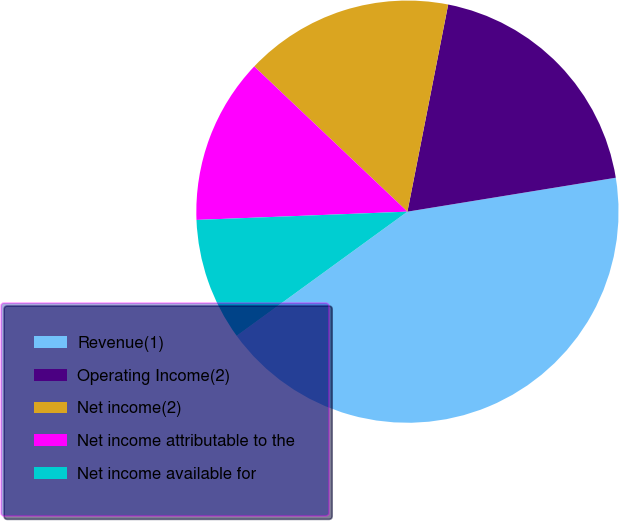Convert chart to OTSL. <chart><loc_0><loc_0><loc_500><loc_500><pie_chart><fcel>Revenue(1)<fcel>Operating Income(2)<fcel>Net income(2)<fcel>Net income attributable to the<fcel>Net income available for<nl><fcel>42.57%<fcel>19.34%<fcel>16.02%<fcel>12.7%<fcel>9.38%<nl></chart> 